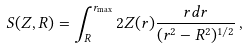Convert formula to latex. <formula><loc_0><loc_0><loc_500><loc_500>S ( Z , R ) = \int _ { R } ^ { r _ { \max } } 2 Z ( r ) \frac { r d r } { ( r ^ { 2 } - R ^ { 2 } ) ^ { 1 / 2 } } \, ,</formula> 